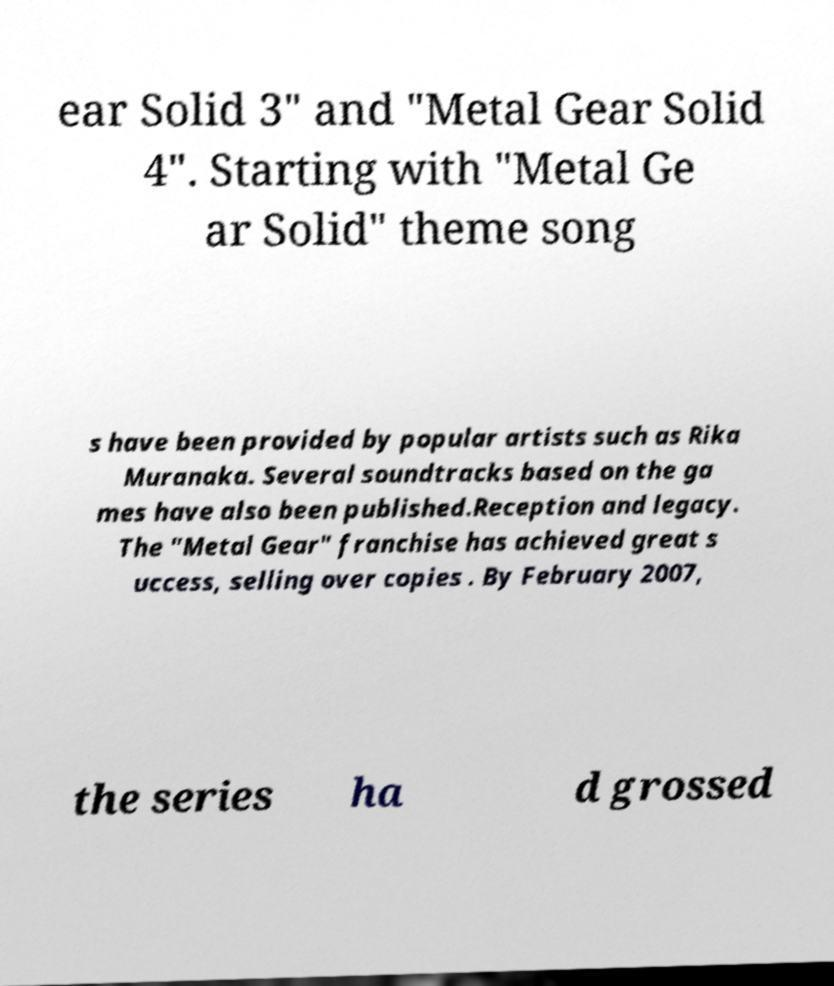Could you extract and type out the text from this image? ear Solid 3" and "Metal Gear Solid 4". Starting with "Metal Ge ar Solid" theme song s have been provided by popular artists such as Rika Muranaka. Several soundtracks based on the ga mes have also been published.Reception and legacy. The "Metal Gear" franchise has achieved great s uccess, selling over copies . By February 2007, the series ha d grossed 